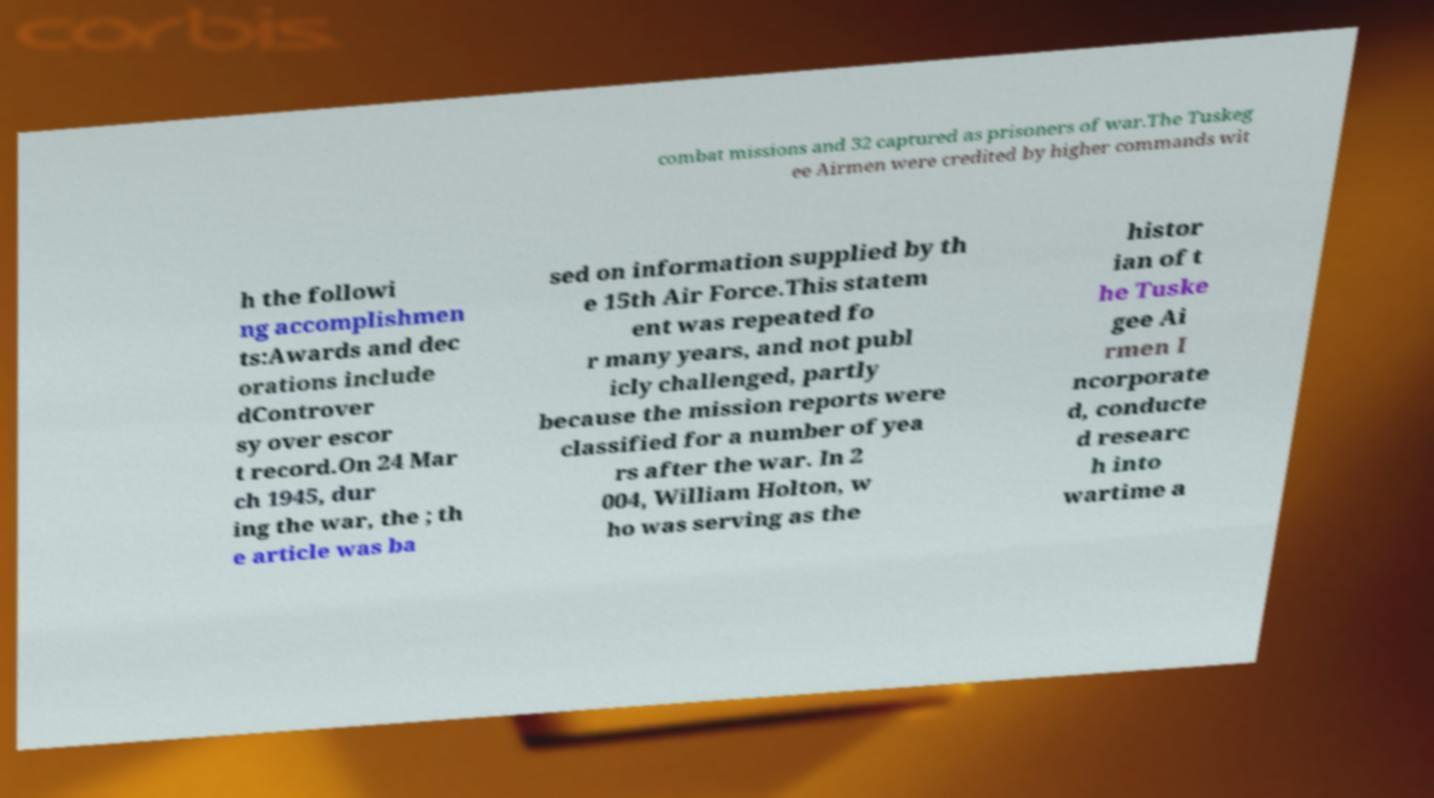Can you read and provide the text displayed in the image?This photo seems to have some interesting text. Can you extract and type it out for me? combat missions and 32 captured as prisoners of war.The Tuskeg ee Airmen were credited by higher commands wit h the followi ng accomplishmen ts:Awards and dec orations include dControver sy over escor t record.On 24 Mar ch 1945, dur ing the war, the ; th e article was ba sed on information supplied by th e 15th Air Force.This statem ent was repeated fo r many years, and not publ icly challenged, partly because the mission reports were classified for a number of yea rs after the war. In 2 004, William Holton, w ho was serving as the histor ian of t he Tuske gee Ai rmen I ncorporate d, conducte d researc h into wartime a 